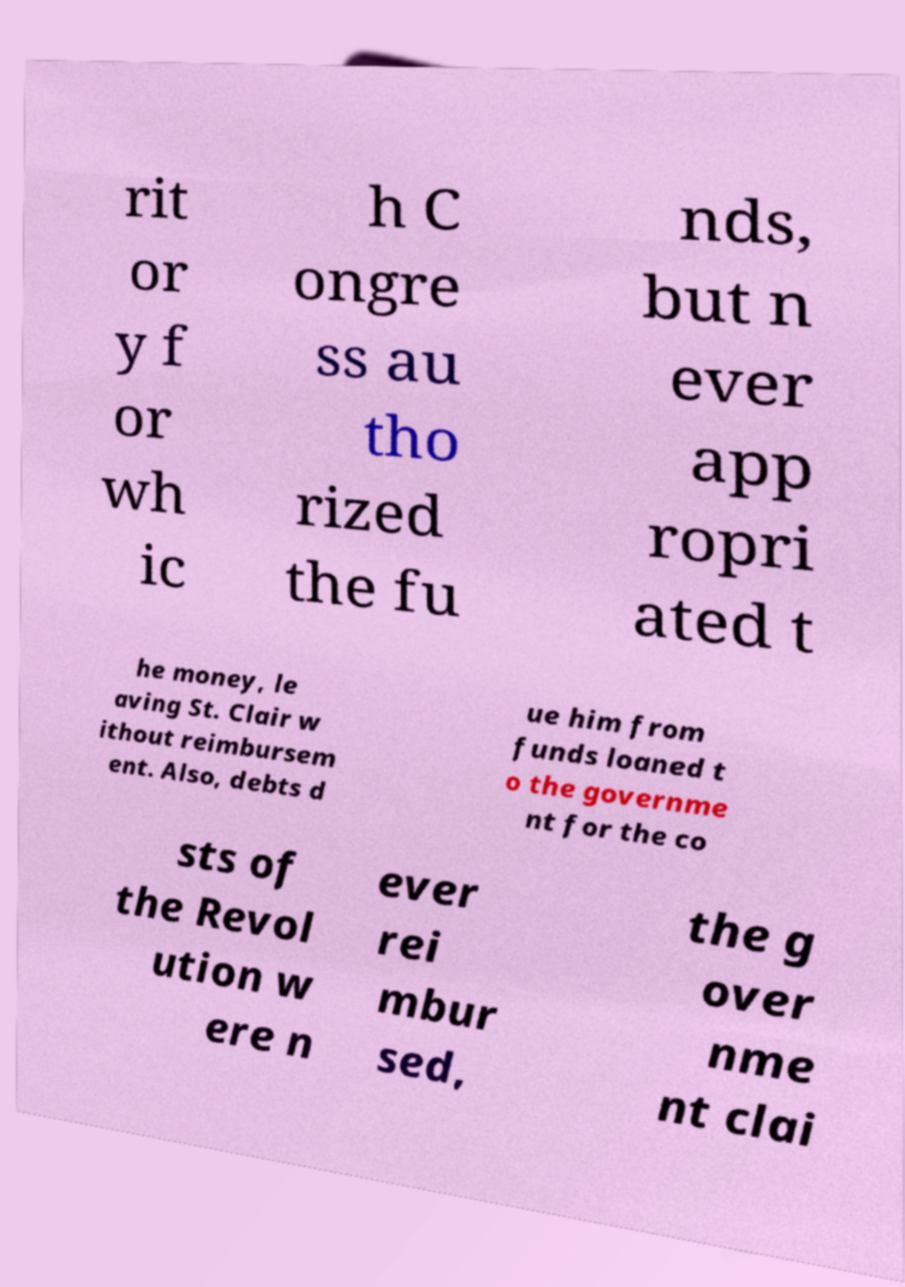What messages or text are displayed in this image? I need them in a readable, typed format. rit or y f or wh ic h C ongre ss au tho rized the fu nds, but n ever app ropri ated t he money, le aving St. Clair w ithout reimbursem ent. Also, debts d ue him from funds loaned t o the governme nt for the co sts of the Revol ution w ere n ever rei mbur sed, the g over nme nt clai 